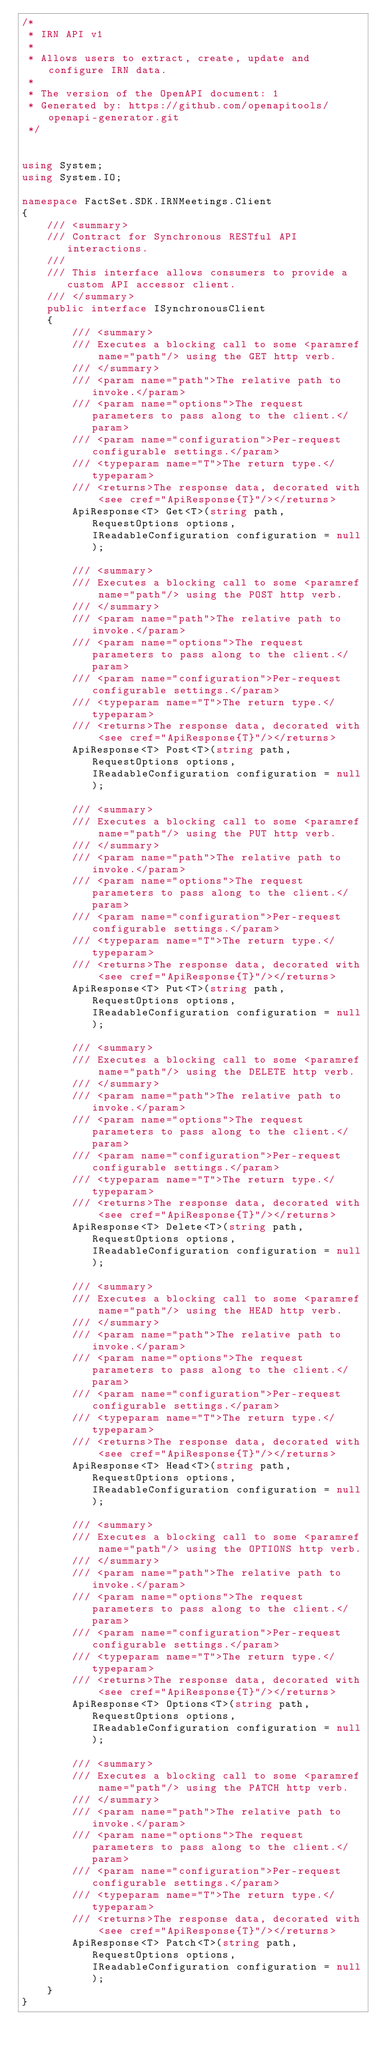<code> <loc_0><loc_0><loc_500><loc_500><_C#_>/*
 * IRN API v1
 *
 * Allows users to extract, create, update and configure IRN data.
 *
 * The version of the OpenAPI document: 1
 * Generated by: https://github.com/openapitools/openapi-generator.git
 */


using System;
using System.IO;

namespace FactSet.SDK.IRNMeetings.Client
{
    /// <summary>
    /// Contract for Synchronous RESTful API interactions.
    ///
    /// This interface allows consumers to provide a custom API accessor client.
    /// </summary>
    public interface ISynchronousClient
    {
        /// <summary>
        /// Executes a blocking call to some <paramref name="path"/> using the GET http verb.
        /// </summary>
        /// <param name="path">The relative path to invoke.</param>
        /// <param name="options">The request parameters to pass along to the client.</param>
        /// <param name="configuration">Per-request configurable settings.</param>
        /// <typeparam name="T">The return type.</typeparam>
        /// <returns>The response data, decorated with <see cref="ApiResponse{T}"/></returns>
        ApiResponse<T> Get<T>(string path, RequestOptions options, IReadableConfiguration configuration = null);

        /// <summary>
        /// Executes a blocking call to some <paramref name="path"/> using the POST http verb.
        /// </summary>
        /// <param name="path">The relative path to invoke.</param>
        /// <param name="options">The request parameters to pass along to the client.</param>
        /// <param name="configuration">Per-request configurable settings.</param>
        /// <typeparam name="T">The return type.</typeparam>
        /// <returns>The response data, decorated with <see cref="ApiResponse{T}"/></returns>
        ApiResponse<T> Post<T>(string path, RequestOptions options, IReadableConfiguration configuration = null);

        /// <summary>
        /// Executes a blocking call to some <paramref name="path"/> using the PUT http verb.
        /// </summary>
        /// <param name="path">The relative path to invoke.</param>
        /// <param name="options">The request parameters to pass along to the client.</param>
        /// <param name="configuration">Per-request configurable settings.</param>
        /// <typeparam name="T">The return type.</typeparam>
        /// <returns>The response data, decorated with <see cref="ApiResponse{T}"/></returns>
        ApiResponse<T> Put<T>(string path, RequestOptions options, IReadableConfiguration configuration = null);

        /// <summary>
        /// Executes a blocking call to some <paramref name="path"/> using the DELETE http verb.
        /// </summary>
        /// <param name="path">The relative path to invoke.</param>
        /// <param name="options">The request parameters to pass along to the client.</param>
        /// <param name="configuration">Per-request configurable settings.</param>
        /// <typeparam name="T">The return type.</typeparam>
        /// <returns>The response data, decorated with <see cref="ApiResponse{T}"/></returns>
        ApiResponse<T> Delete<T>(string path, RequestOptions options, IReadableConfiguration configuration = null);

        /// <summary>
        /// Executes a blocking call to some <paramref name="path"/> using the HEAD http verb.
        /// </summary>
        /// <param name="path">The relative path to invoke.</param>
        /// <param name="options">The request parameters to pass along to the client.</param>
        /// <param name="configuration">Per-request configurable settings.</param>
        /// <typeparam name="T">The return type.</typeparam>
        /// <returns>The response data, decorated with <see cref="ApiResponse{T}"/></returns>
        ApiResponse<T> Head<T>(string path, RequestOptions options, IReadableConfiguration configuration = null);

        /// <summary>
        /// Executes a blocking call to some <paramref name="path"/> using the OPTIONS http verb.
        /// </summary>
        /// <param name="path">The relative path to invoke.</param>
        /// <param name="options">The request parameters to pass along to the client.</param>
        /// <param name="configuration">Per-request configurable settings.</param>
        /// <typeparam name="T">The return type.</typeparam>
        /// <returns>The response data, decorated with <see cref="ApiResponse{T}"/></returns>
        ApiResponse<T> Options<T>(string path, RequestOptions options, IReadableConfiguration configuration = null);

        /// <summary>
        /// Executes a blocking call to some <paramref name="path"/> using the PATCH http verb.
        /// </summary>
        /// <param name="path">The relative path to invoke.</param>
        /// <param name="options">The request parameters to pass along to the client.</param>
        /// <param name="configuration">Per-request configurable settings.</param>
        /// <typeparam name="T">The return type.</typeparam>
        /// <returns>The response data, decorated with <see cref="ApiResponse{T}"/></returns>
        ApiResponse<T> Patch<T>(string path, RequestOptions options, IReadableConfiguration configuration = null);
    }
}
</code> 